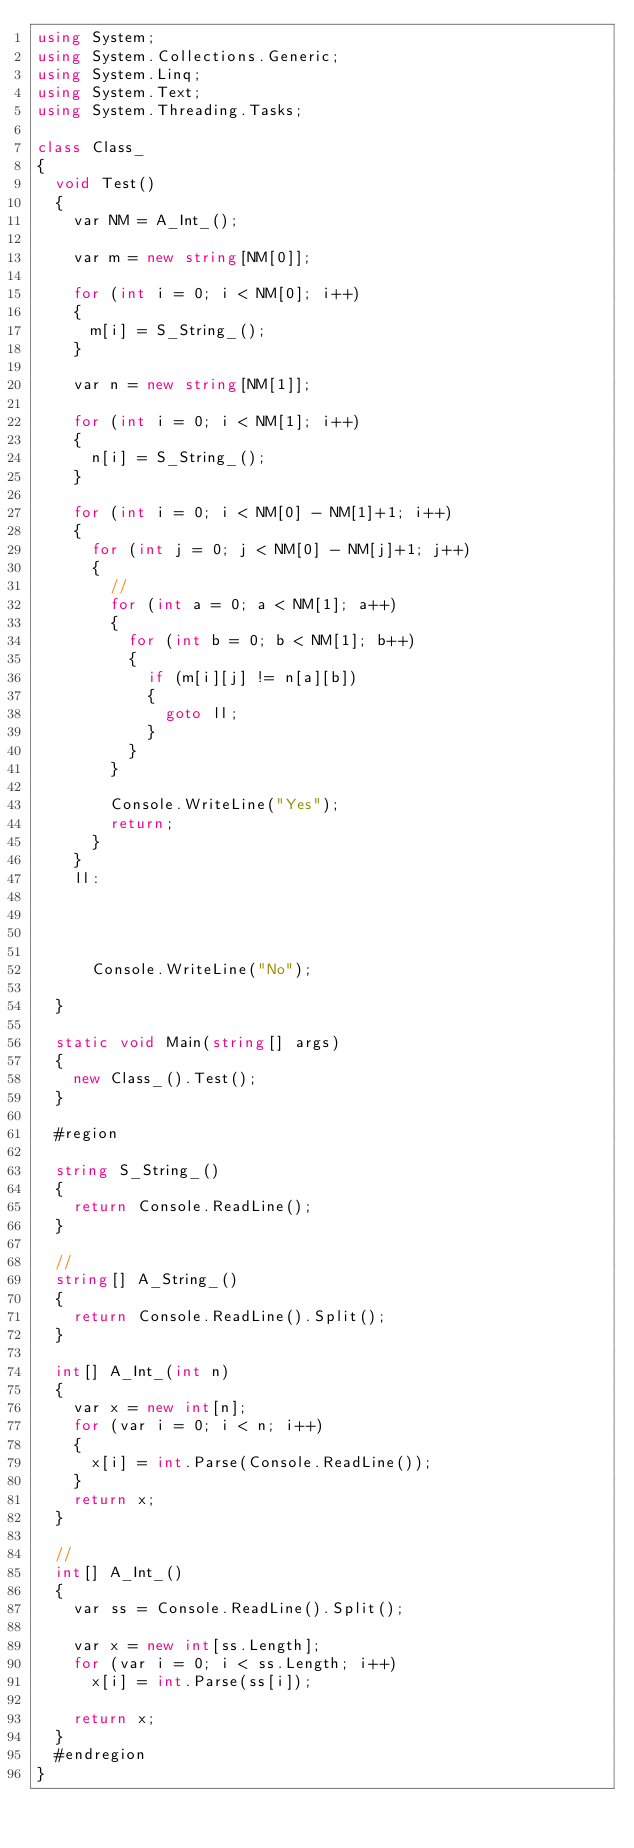<code> <loc_0><loc_0><loc_500><loc_500><_C#_>using System;
using System.Collections.Generic;
using System.Linq;
using System.Text;
using System.Threading.Tasks;

class Class_
{
	void Test()
	{
		var NM = A_Int_();

		var m = new string[NM[0]];

		for (int i = 0; i < NM[0]; i++)
		{
			m[i] = S_String_();
		}

		var n = new string[NM[1]];

		for (int i = 0; i < NM[1]; i++)
		{
			n[i] = S_String_();
		}

		for (int i = 0; i < NM[0] - NM[1]+1; i++)
		{
			for (int j = 0; j < NM[0] - NM[j]+1; j++)
			{
				//
				for (int a = 0; a < NM[1]; a++)
				{
					for (int b = 0; b < NM[1]; b++)
					{
						if (m[i][j] != n[a][b])
						{
							goto ll;
						}
					}
				}

				Console.WriteLine("Yes");
				return;
			}
		}
		ll:
	



			Console.WriteLine("No");

	}

	static void Main(string[] args)
  {
    new Class_().Test();
  }

  #region

  string S_String_()
  {
    return Console.ReadLine();
  }

	//
	string[] A_String_()
  {
    return Console.ReadLine().Split();
  }

  int[] A_Int_(int n)
  {
    var x = new int[n];
    for (var i = 0; i < n; i++)
    {
      x[i] = int.Parse(Console.ReadLine());
    }
    return x;
  }

	//
	int[] A_Int_()
  {
    var ss = Console.ReadLine().Split();

    var x = new int[ss.Length];
    for (var i = 0; i < ss.Length; i++)
      x[i] = int.Parse(ss[i]);

    return x;
  }
  #endregion
}
	</code> 